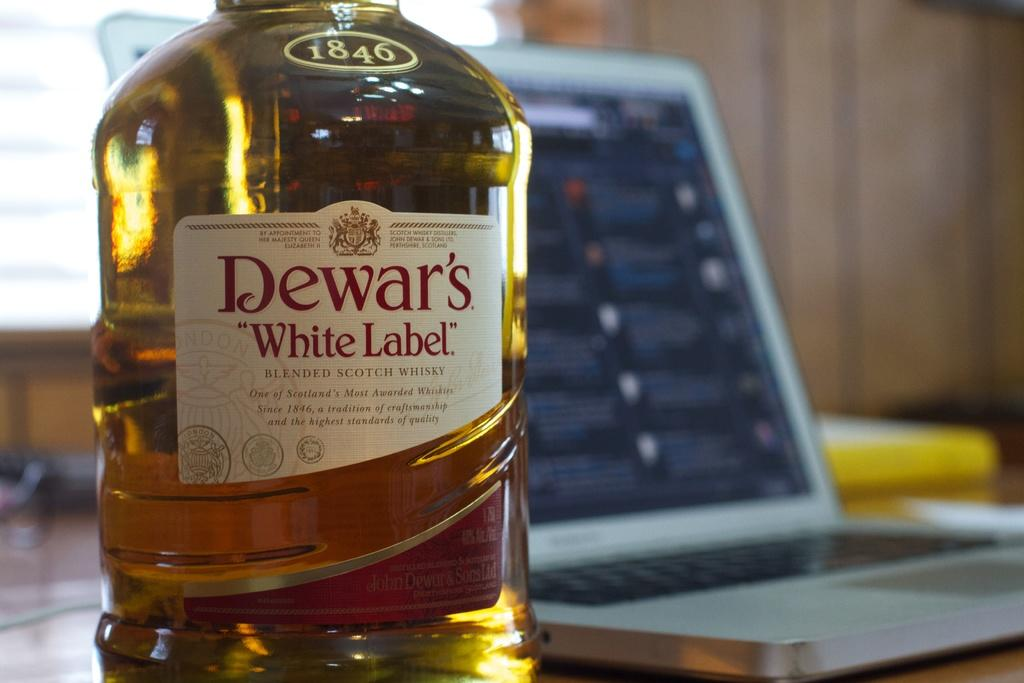What is contained in the bottle that is visible in the image? There is a drink in the bottle that is visible in the image. What additional detail can be observed on the bottle? The bottle has a sticker on it. What electronic device is present in the image? There is a laptop in the image. Where are the bottle and laptop located in the image? The bottle and laptop are placed on a table. What can be seen in the background of the image? There is a wall visible in the background of the image. How many pears are sitting on the laptop in the image? There are no pears present in the image, and they are not sitting on the laptop. What health benefits can be gained from the drink in the bottle? The provided facts do not mention any specific health benefits of the drink in the bottle, so it cannot be determined from the image. 